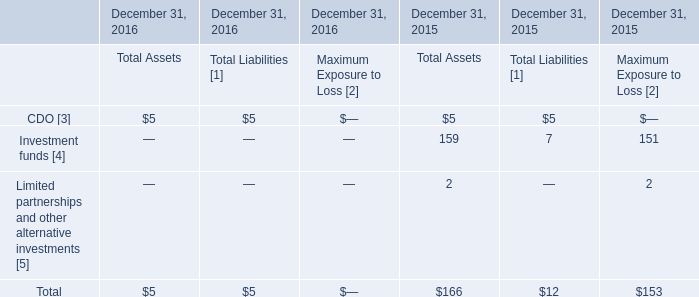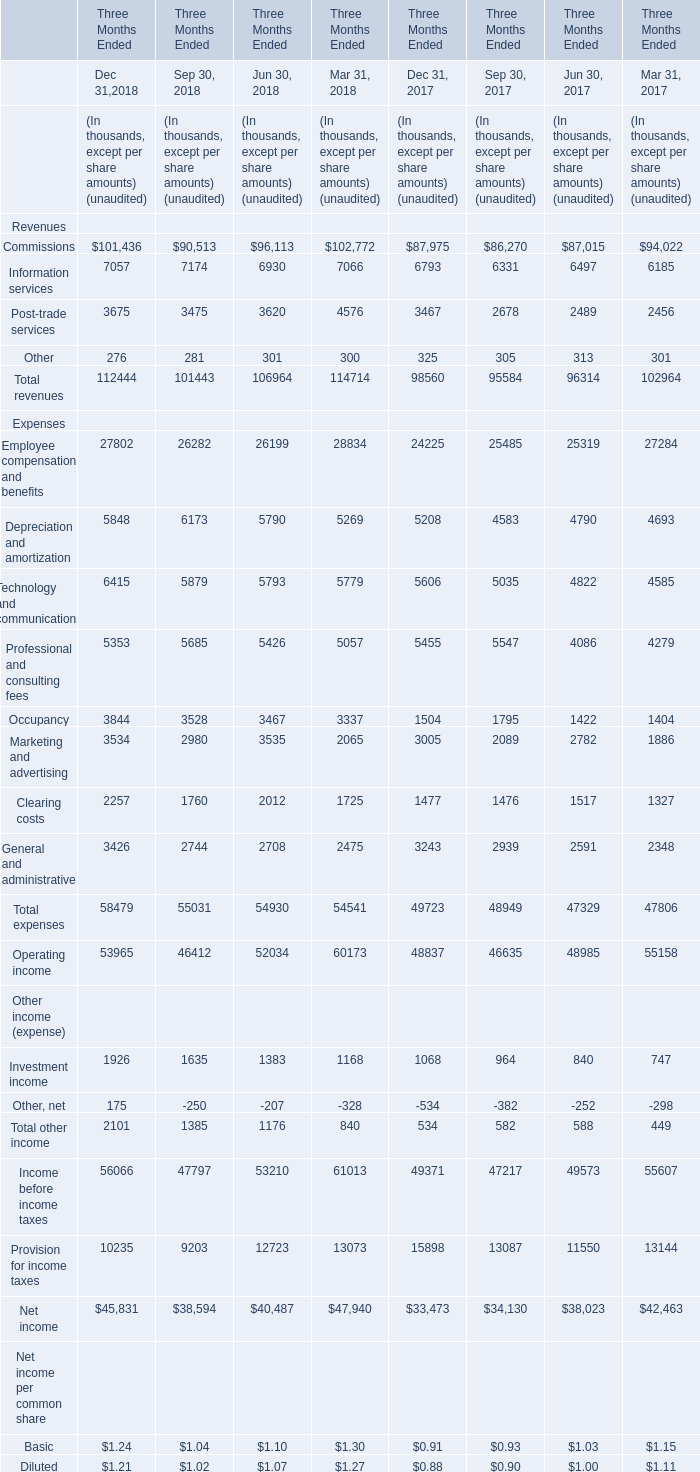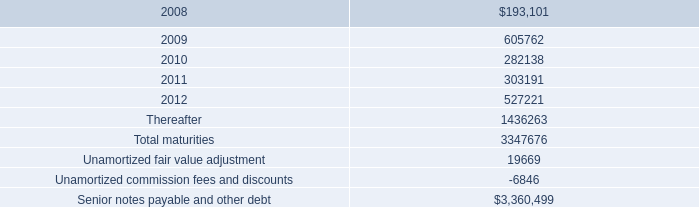What do all Revenues sum up for Dec 31,2018 , excluding Commissions and Information services? (in thousand) 
Computations: (3675 + 276)
Answer: 3951.0. 